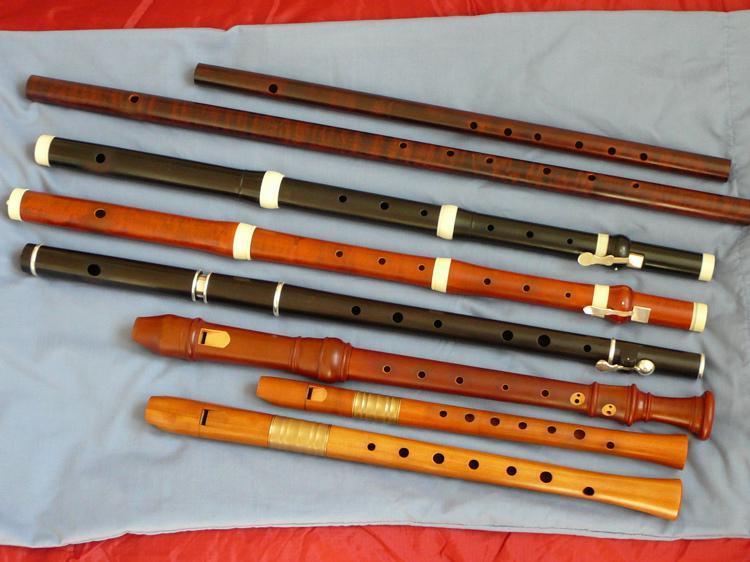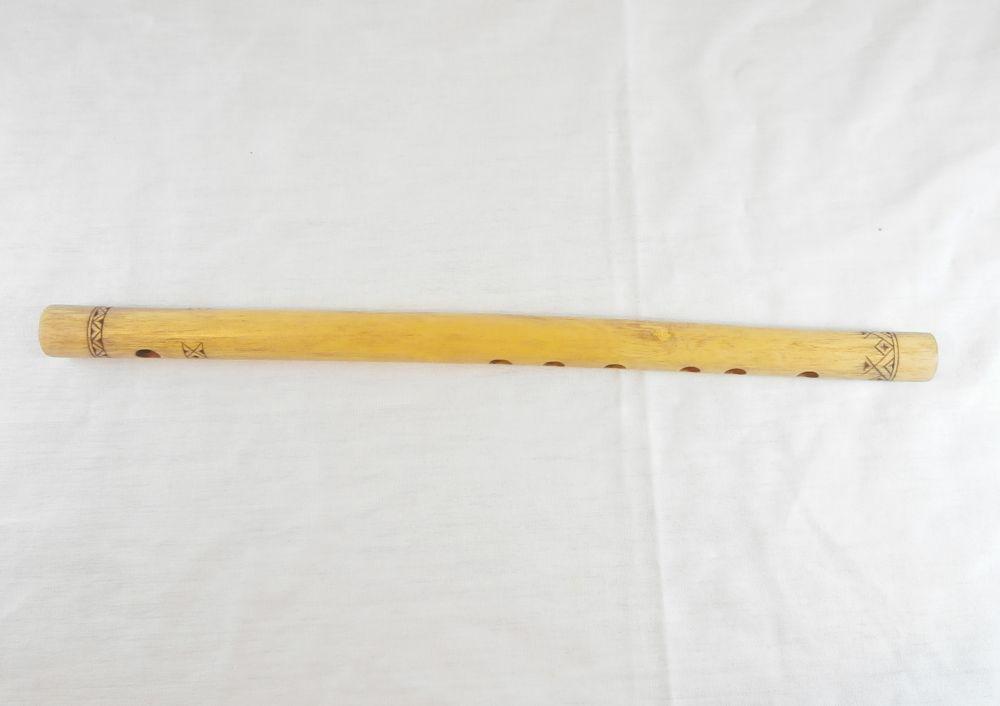The first image is the image on the left, the second image is the image on the right. Analyze the images presented: Is the assertion "The flutes in one of the images are arranged with top to bottom from smallest to largest." valid? Answer yes or no. No. 